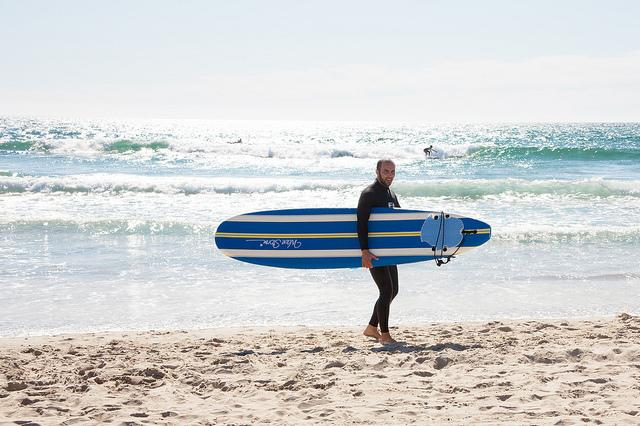What type of outfit is the man wearing? wet suit 